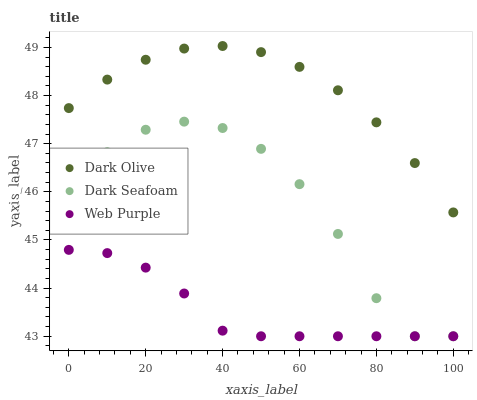Does Web Purple have the minimum area under the curve?
Answer yes or no. Yes. Does Dark Olive have the maximum area under the curve?
Answer yes or no. Yes. Does Dark Olive have the minimum area under the curve?
Answer yes or no. No. Does Web Purple have the maximum area under the curve?
Answer yes or no. No. Is Web Purple the smoothest?
Answer yes or no. Yes. Is Dark Seafoam the roughest?
Answer yes or no. Yes. Is Dark Olive the smoothest?
Answer yes or no. No. Is Dark Olive the roughest?
Answer yes or no. No. Does Dark Seafoam have the lowest value?
Answer yes or no. Yes. Does Dark Olive have the lowest value?
Answer yes or no. No. Does Dark Olive have the highest value?
Answer yes or no. Yes. Does Web Purple have the highest value?
Answer yes or no. No. Is Web Purple less than Dark Olive?
Answer yes or no. Yes. Is Dark Olive greater than Web Purple?
Answer yes or no. Yes. Does Dark Seafoam intersect Web Purple?
Answer yes or no. Yes. Is Dark Seafoam less than Web Purple?
Answer yes or no. No. Is Dark Seafoam greater than Web Purple?
Answer yes or no. No. Does Web Purple intersect Dark Olive?
Answer yes or no. No. 